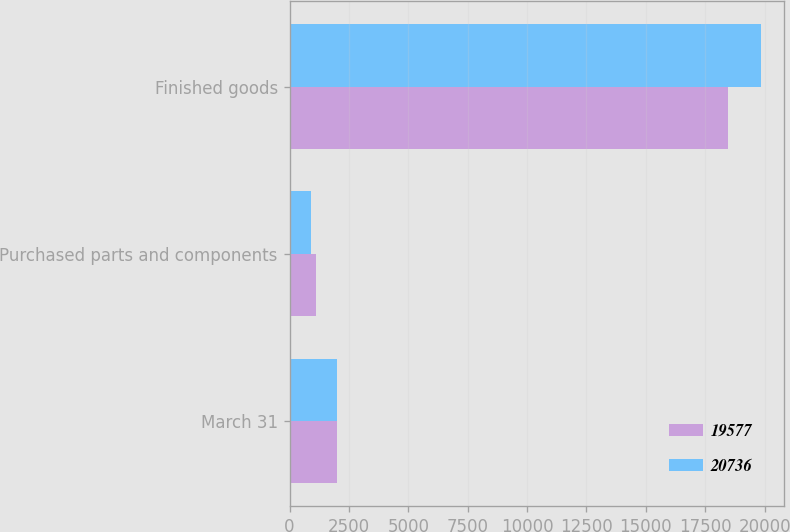Convert chart to OTSL. <chart><loc_0><loc_0><loc_500><loc_500><stacked_bar_chart><ecel><fcel>March 31<fcel>Purchased parts and components<fcel>Finished goods<nl><fcel>19577<fcel>2003<fcel>1129<fcel>18448<nl><fcel>20736<fcel>2002<fcel>892<fcel>19844<nl></chart> 